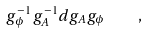Convert formula to latex. <formula><loc_0><loc_0><loc_500><loc_500>g _ { \phi } ^ { - 1 } g _ { A } ^ { - 1 } d g _ { A } g _ { \phi } \quad ,</formula> 